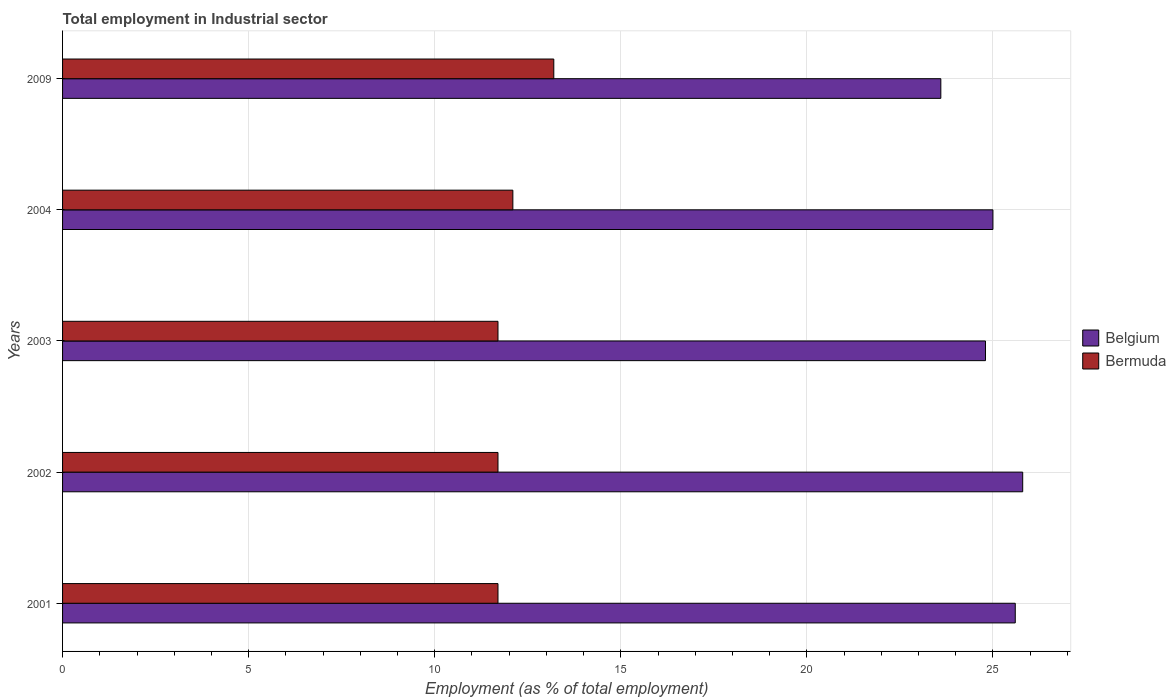How many groups of bars are there?
Your response must be concise. 5. Are the number of bars per tick equal to the number of legend labels?
Your answer should be very brief. Yes. What is the label of the 4th group of bars from the top?
Offer a terse response. 2002. In how many cases, is the number of bars for a given year not equal to the number of legend labels?
Your response must be concise. 0. What is the employment in industrial sector in Bermuda in 2001?
Ensure brevity in your answer.  11.7. Across all years, what is the maximum employment in industrial sector in Belgium?
Your response must be concise. 25.8. Across all years, what is the minimum employment in industrial sector in Belgium?
Keep it short and to the point. 23.6. In which year was the employment in industrial sector in Belgium maximum?
Provide a succinct answer. 2002. What is the total employment in industrial sector in Belgium in the graph?
Your answer should be compact. 124.8. What is the difference between the employment in industrial sector in Bermuda in 2003 and the employment in industrial sector in Belgium in 2002?
Keep it short and to the point. -14.1. What is the average employment in industrial sector in Bermuda per year?
Make the answer very short. 12.08. In the year 2003, what is the difference between the employment in industrial sector in Bermuda and employment in industrial sector in Belgium?
Your answer should be very brief. -13.1. In how many years, is the employment in industrial sector in Belgium greater than 23 %?
Offer a very short reply. 5. What is the ratio of the employment in industrial sector in Belgium in 2004 to that in 2009?
Offer a very short reply. 1.06. What is the difference between the highest and the second highest employment in industrial sector in Belgium?
Your answer should be very brief. 0.2. What is the difference between the highest and the lowest employment in industrial sector in Belgium?
Your response must be concise. 2.2. Is the sum of the employment in industrial sector in Bermuda in 2002 and 2004 greater than the maximum employment in industrial sector in Belgium across all years?
Keep it short and to the point. No. What is the difference between two consecutive major ticks on the X-axis?
Offer a very short reply. 5. What is the title of the graph?
Give a very brief answer. Total employment in Industrial sector. What is the label or title of the X-axis?
Ensure brevity in your answer.  Employment (as % of total employment). What is the Employment (as % of total employment) in Belgium in 2001?
Make the answer very short. 25.6. What is the Employment (as % of total employment) of Bermuda in 2001?
Your answer should be compact. 11.7. What is the Employment (as % of total employment) in Belgium in 2002?
Make the answer very short. 25.8. What is the Employment (as % of total employment) in Bermuda in 2002?
Make the answer very short. 11.7. What is the Employment (as % of total employment) in Belgium in 2003?
Your response must be concise. 24.8. What is the Employment (as % of total employment) in Bermuda in 2003?
Provide a short and direct response. 11.7. What is the Employment (as % of total employment) in Bermuda in 2004?
Your answer should be very brief. 12.1. What is the Employment (as % of total employment) of Belgium in 2009?
Give a very brief answer. 23.6. What is the Employment (as % of total employment) in Bermuda in 2009?
Keep it short and to the point. 13.2. Across all years, what is the maximum Employment (as % of total employment) in Belgium?
Your answer should be very brief. 25.8. Across all years, what is the maximum Employment (as % of total employment) of Bermuda?
Provide a short and direct response. 13.2. Across all years, what is the minimum Employment (as % of total employment) of Belgium?
Offer a very short reply. 23.6. Across all years, what is the minimum Employment (as % of total employment) of Bermuda?
Provide a succinct answer. 11.7. What is the total Employment (as % of total employment) in Belgium in the graph?
Provide a succinct answer. 124.8. What is the total Employment (as % of total employment) of Bermuda in the graph?
Your response must be concise. 60.4. What is the difference between the Employment (as % of total employment) in Bermuda in 2001 and that in 2002?
Your answer should be compact. 0. What is the difference between the Employment (as % of total employment) of Belgium in 2001 and that in 2004?
Offer a terse response. 0.6. What is the difference between the Employment (as % of total employment) of Bermuda in 2001 and that in 2004?
Ensure brevity in your answer.  -0.4. What is the difference between the Employment (as % of total employment) of Belgium in 2001 and that in 2009?
Keep it short and to the point. 2. What is the difference between the Employment (as % of total employment) in Bermuda in 2002 and that in 2003?
Your response must be concise. 0. What is the difference between the Employment (as % of total employment) in Belgium in 2002 and that in 2004?
Provide a succinct answer. 0.8. What is the difference between the Employment (as % of total employment) of Bermuda in 2002 and that in 2004?
Offer a terse response. -0.4. What is the difference between the Employment (as % of total employment) in Bermuda in 2002 and that in 2009?
Your answer should be compact. -1.5. What is the difference between the Employment (as % of total employment) in Bermuda in 2003 and that in 2004?
Make the answer very short. -0.4. What is the difference between the Employment (as % of total employment) in Bermuda in 2003 and that in 2009?
Provide a short and direct response. -1.5. What is the difference between the Employment (as % of total employment) of Bermuda in 2004 and that in 2009?
Ensure brevity in your answer.  -1.1. What is the difference between the Employment (as % of total employment) of Belgium in 2002 and the Employment (as % of total employment) of Bermuda in 2003?
Your answer should be compact. 14.1. What is the difference between the Employment (as % of total employment) of Belgium in 2002 and the Employment (as % of total employment) of Bermuda in 2004?
Offer a terse response. 13.7. What is the difference between the Employment (as % of total employment) of Belgium in 2002 and the Employment (as % of total employment) of Bermuda in 2009?
Give a very brief answer. 12.6. What is the difference between the Employment (as % of total employment) in Belgium in 2004 and the Employment (as % of total employment) in Bermuda in 2009?
Provide a succinct answer. 11.8. What is the average Employment (as % of total employment) in Belgium per year?
Your response must be concise. 24.96. What is the average Employment (as % of total employment) of Bermuda per year?
Provide a succinct answer. 12.08. In the year 2001, what is the difference between the Employment (as % of total employment) in Belgium and Employment (as % of total employment) in Bermuda?
Ensure brevity in your answer.  13.9. In the year 2002, what is the difference between the Employment (as % of total employment) in Belgium and Employment (as % of total employment) in Bermuda?
Offer a terse response. 14.1. In the year 2004, what is the difference between the Employment (as % of total employment) in Belgium and Employment (as % of total employment) in Bermuda?
Ensure brevity in your answer.  12.9. In the year 2009, what is the difference between the Employment (as % of total employment) in Belgium and Employment (as % of total employment) in Bermuda?
Offer a very short reply. 10.4. What is the ratio of the Employment (as % of total employment) of Belgium in 2001 to that in 2003?
Give a very brief answer. 1.03. What is the ratio of the Employment (as % of total employment) of Bermuda in 2001 to that in 2004?
Provide a short and direct response. 0.97. What is the ratio of the Employment (as % of total employment) of Belgium in 2001 to that in 2009?
Your answer should be very brief. 1.08. What is the ratio of the Employment (as % of total employment) in Bermuda in 2001 to that in 2009?
Provide a succinct answer. 0.89. What is the ratio of the Employment (as % of total employment) in Belgium in 2002 to that in 2003?
Your response must be concise. 1.04. What is the ratio of the Employment (as % of total employment) in Belgium in 2002 to that in 2004?
Offer a terse response. 1.03. What is the ratio of the Employment (as % of total employment) in Bermuda in 2002 to that in 2004?
Make the answer very short. 0.97. What is the ratio of the Employment (as % of total employment) in Belgium in 2002 to that in 2009?
Keep it short and to the point. 1.09. What is the ratio of the Employment (as % of total employment) in Bermuda in 2002 to that in 2009?
Ensure brevity in your answer.  0.89. What is the ratio of the Employment (as % of total employment) in Belgium in 2003 to that in 2004?
Your answer should be very brief. 0.99. What is the ratio of the Employment (as % of total employment) in Bermuda in 2003 to that in 2004?
Ensure brevity in your answer.  0.97. What is the ratio of the Employment (as % of total employment) of Belgium in 2003 to that in 2009?
Give a very brief answer. 1.05. What is the ratio of the Employment (as % of total employment) in Bermuda in 2003 to that in 2009?
Your answer should be compact. 0.89. What is the ratio of the Employment (as % of total employment) in Belgium in 2004 to that in 2009?
Provide a succinct answer. 1.06. What is the difference between the highest and the second highest Employment (as % of total employment) of Belgium?
Provide a succinct answer. 0.2. What is the difference between the highest and the second highest Employment (as % of total employment) of Bermuda?
Provide a short and direct response. 1.1. What is the difference between the highest and the lowest Employment (as % of total employment) in Belgium?
Your answer should be very brief. 2.2. What is the difference between the highest and the lowest Employment (as % of total employment) of Bermuda?
Make the answer very short. 1.5. 